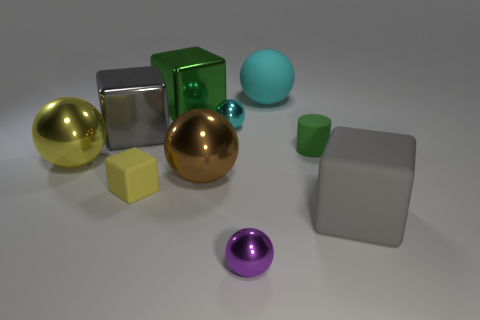Subtract all purple spheres. How many spheres are left? 4 Subtract all big cyan spheres. How many spheres are left? 4 Subtract 1 cubes. How many cubes are left? 3 Subtract all red cubes. Subtract all cyan cylinders. How many cubes are left? 4 Subtract all cylinders. How many objects are left? 9 Add 9 purple shiny things. How many purple shiny things exist? 10 Subtract 0 blue cylinders. How many objects are left? 10 Subtract all purple metal spheres. Subtract all yellow shiny spheres. How many objects are left? 8 Add 2 large green cubes. How many large green cubes are left? 3 